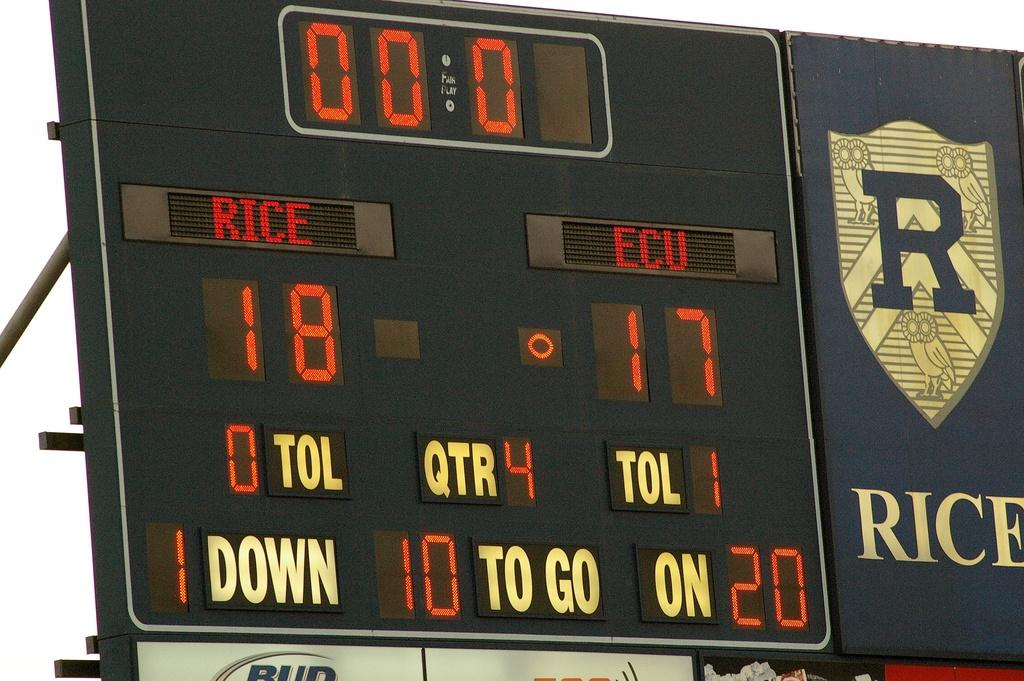<image>
Present a compact description of the photo's key features. the numbers 18 and 17 on a scoreboard 